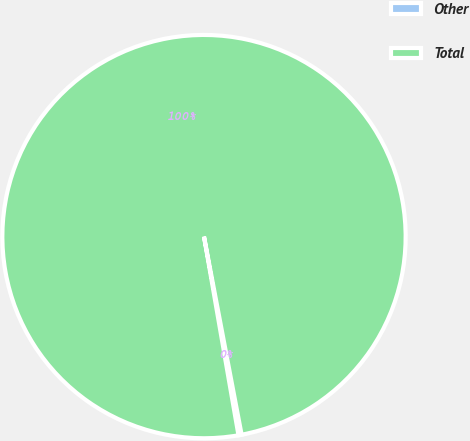<chart> <loc_0><loc_0><loc_500><loc_500><pie_chart><fcel>Other<fcel>Total<nl><fcel>0.25%<fcel>99.75%<nl></chart> 